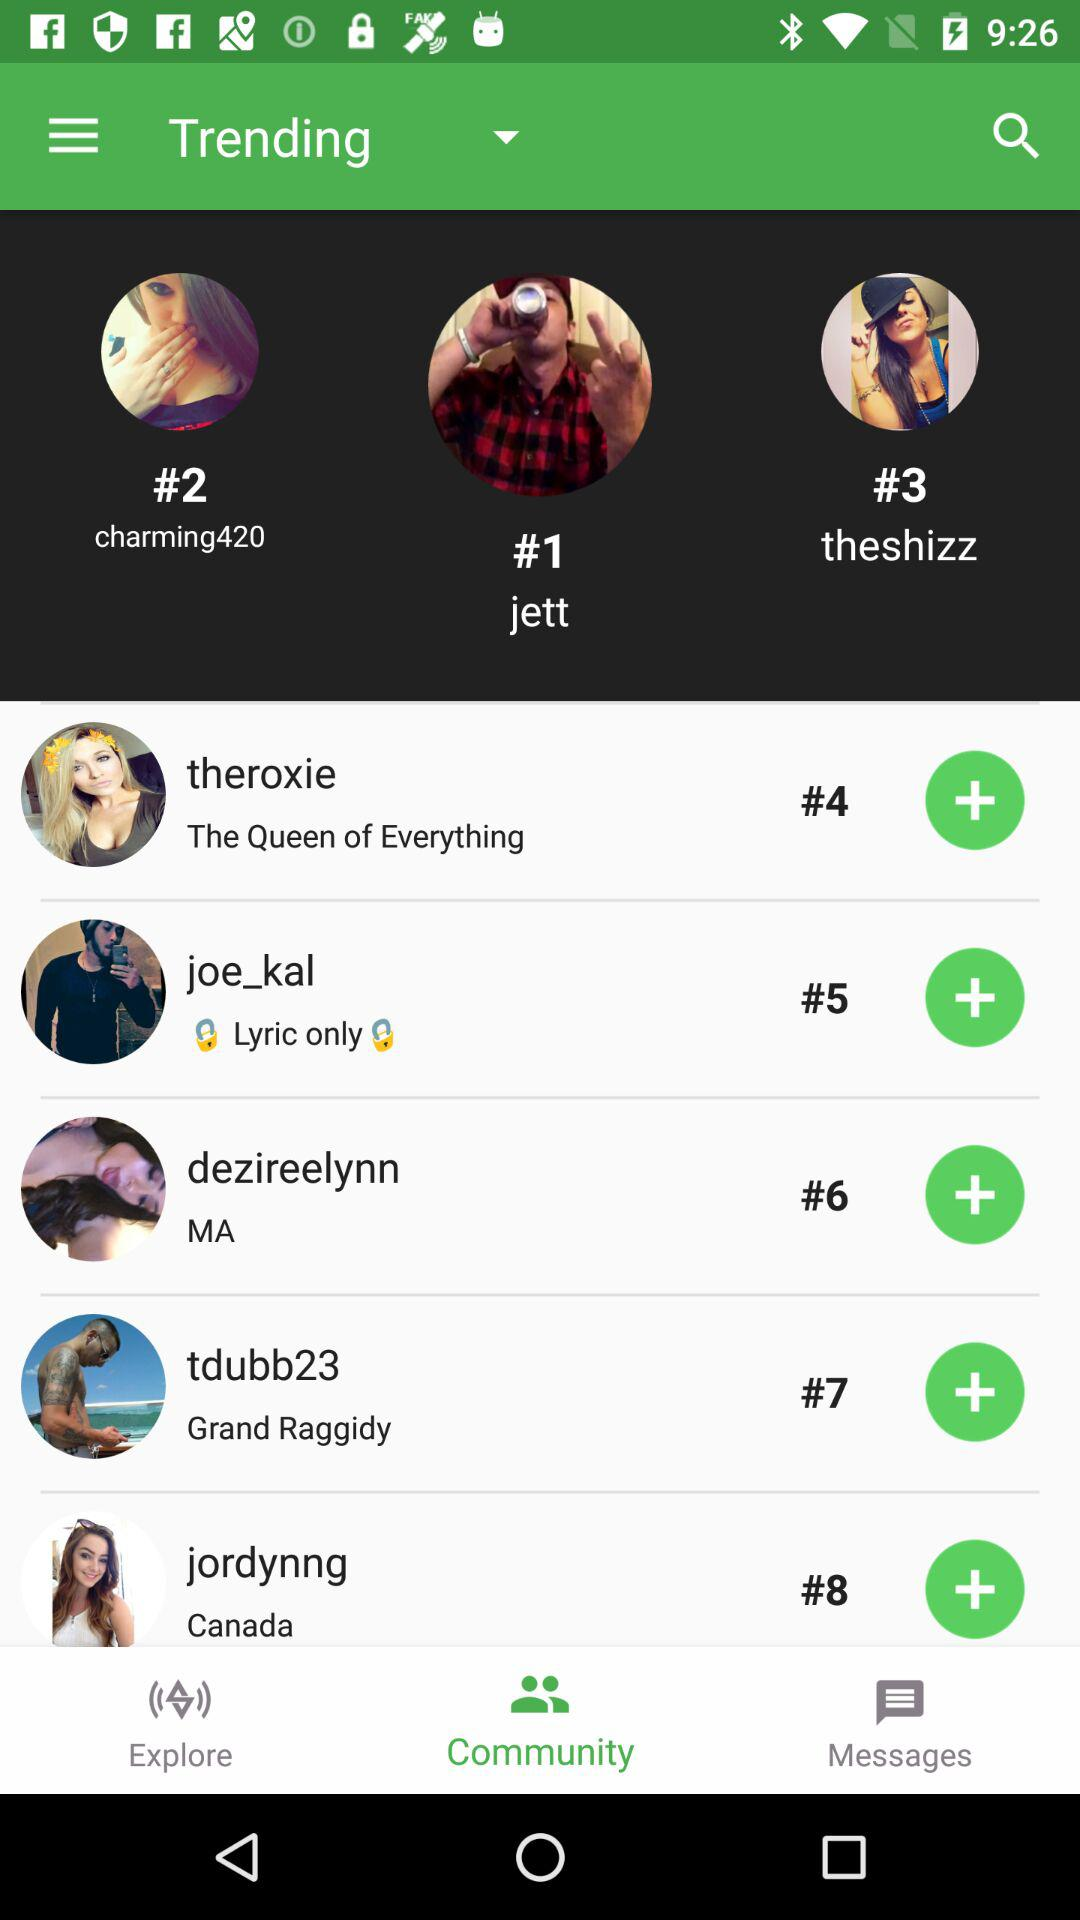Which tab is selected? The selected tab is "Community". 